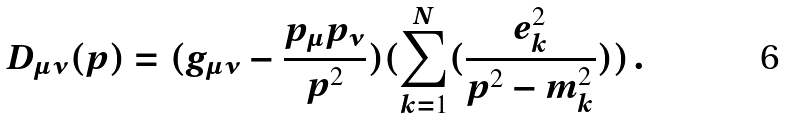Convert formula to latex. <formula><loc_0><loc_0><loc_500><loc_500>D _ { \mu \nu } ( p ) = ( g _ { \mu \nu } - \frac { p _ { \mu } p _ { \nu } } { p ^ { 2 } } ) ( \sum ^ { N } _ { k = 1 } ( \frac { e ^ { 2 } _ { k } } { p ^ { 2 } - m ^ { 2 } _ { k } } ) ) \, .</formula> 